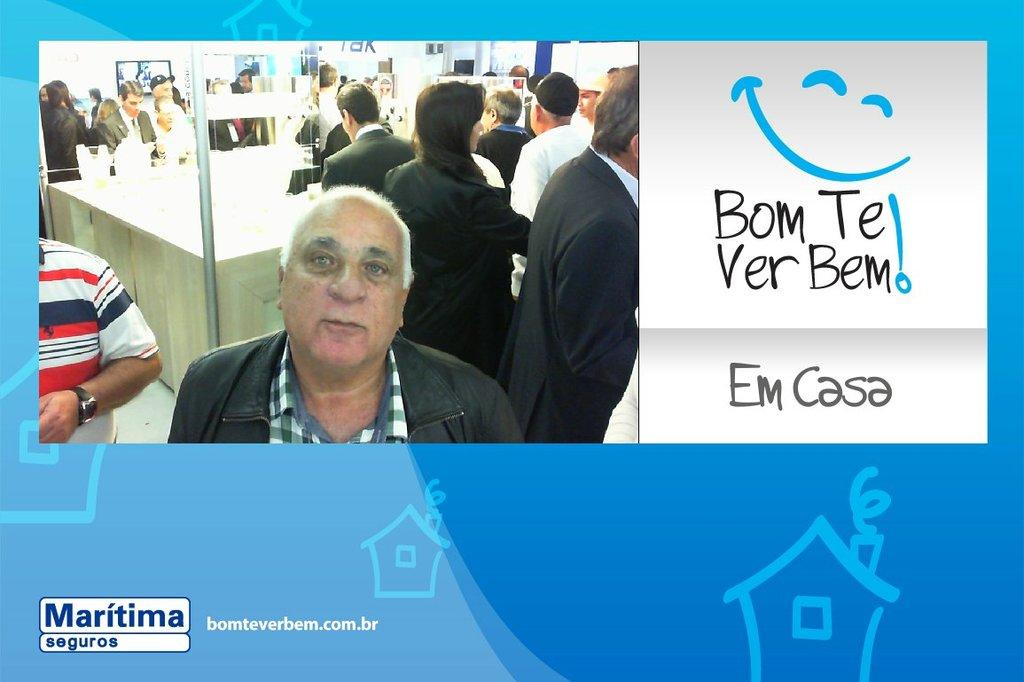Provide a one-sentence caption for the provided image. Man next to a smiley face sign that says Bom Te Ver Bem!. 